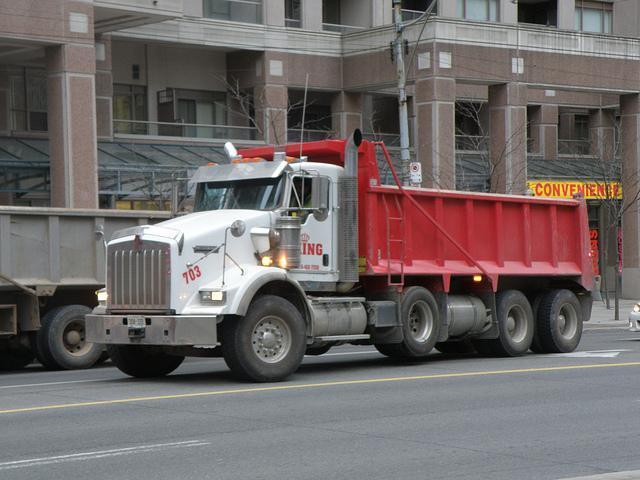How many tires does this truck need?
Give a very brief answer. 8. How many trucks are visible?
Give a very brief answer. 2. 